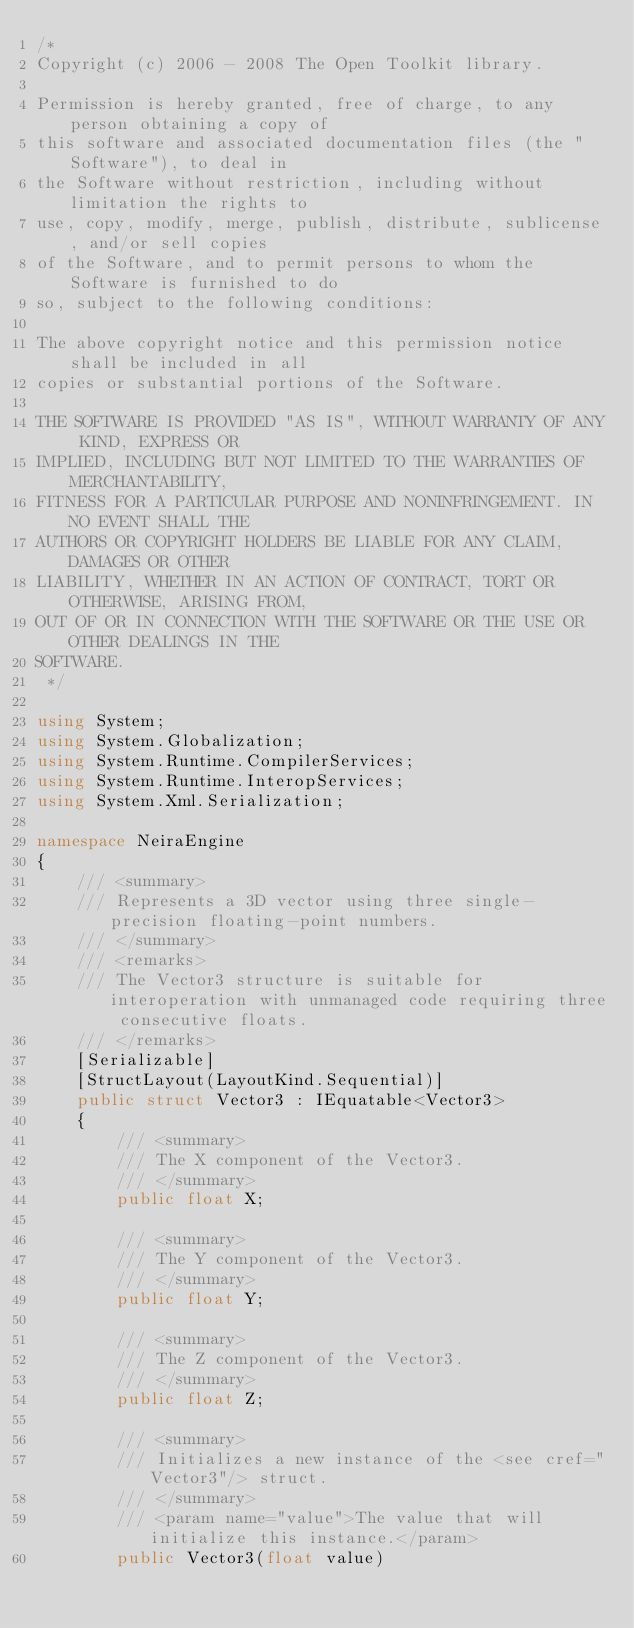Convert code to text. <code><loc_0><loc_0><loc_500><loc_500><_C#_>/*
Copyright (c) 2006 - 2008 The Open Toolkit library.

Permission is hereby granted, free of charge, to any person obtaining a copy of
this software and associated documentation files (the "Software"), to deal in
the Software without restriction, including without limitation the rights to
use, copy, modify, merge, publish, distribute, sublicense, and/or sell copies
of the Software, and to permit persons to whom the Software is furnished to do
so, subject to the following conditions:

The above copyright notice and this permission notice shall be included in all
copies or substantial portions of the Software.

THE SOFTWARE IS PROVIDED "AS IS", WITHOUT WARRANTY OF ANY KIND, EXPRESS OR
IMPLIED, INCLUDING BUT NOT LIMITED TO THE WARRANTIES OF MERCHANTABILITY,
FITNESS FOR A PARTICULAR PURPOSE AND NONINFRINGEMENT. IN NO EVENT SHALL THE
AUTHORS OR COPYRIGHT HOLDERS BE LIABLE FOR ANY CLAIM, DAMAGES OR OTHER
LIABILITY, WHETHER IN AN ACTION OF CONTRACT, TORT OR OTHERWISE, ARISING FROM,
OUT OF OR IN CONNECTION WITH THE SOFTWARE OR THE USE OR OTHER DEALINGS IN THE
SOFTWARE.
 */

using System;
using System.Globalization;
using System.Runtime.CompilerServices;
using System.Runtime.InteropServices;
using System.Xml.Serialization;

namespace NeiraEngine
{
    /// <summary>
    /// Represents a 3D vector using three single-precision floating-point numbers.
    /// </summary>
    /// <remarks>
    /// The Vector3 structure is suitable for interoperation with unmanaged code requiring three consecutive floats.
    /// </remarks>
    [Serializable]
    [StructLayout(LayoutKind.Sequential)]
    public struct Vector3 : IEquatable<Vector3>
    {
        /// <summary>
        /// The X component of the Vector3.
        /// </summary>
        public float X;

        /// <summary>
        /// The Y component of the Vector3.
        /// </summary>
        public float Y;

        /// <summary>
        /// The Z component of the Vector3.
        /// </summary>
        public float Z;

        /// <summary>
        /// Initializes a new instance of the <see cref="Vector3"/> struct.
        /// </summary>
        /// <param name="value">The value that will initialize this instance.</param>
        public Vector3(float value)</code> 